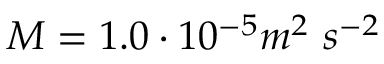Convert formula to latex. <formula><loc_0><loc_0><loc_500><loc_500>M = 1 . 0 \cdot 1 0 ^ { - 5 } m ^ { 2 } \ s ^ { - 2 }</formula> 